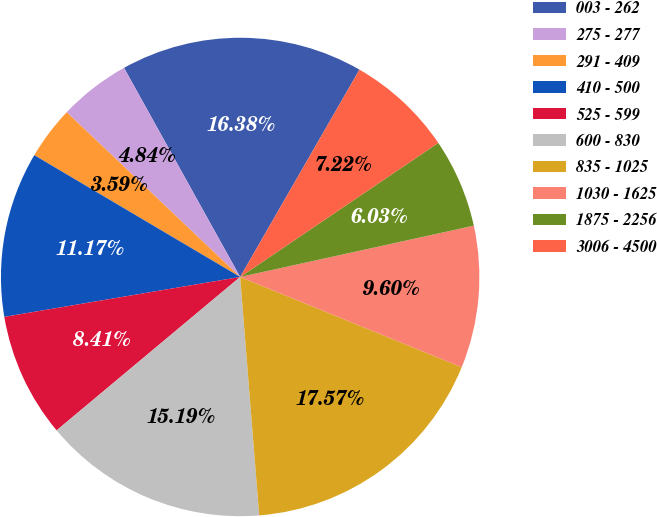Convert chart. <chart><loc_0><loc_0><loc_500><loc_500><pie_chart><fcel>003 - 262<fcel>275 - 277<fcel>291 - 409<fcel>410 - 500<fcel>525 - 599<fcel>600 - 830<fcel>835 - 1025<fcel>1030 - 1625<fcel>1875 - 2256<fcel>3006 - 4500<nl><fcel>16.38%<fcel>4.84%<fcel>3.59%<fcel>11.17%<fcel>8.41%<fcel>15.19%<fcel>17.57%<fcel>9.6%<fcel>6.03%<fcel>7.22%<nl></chart> 